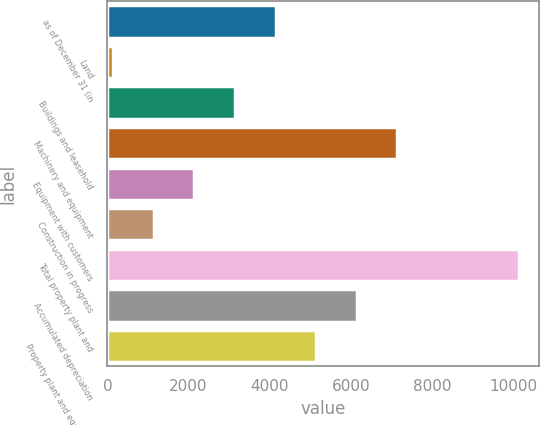Convert chart to OTSL. <chart><loc_0><loc_0><loc_500><loc_500><bar_chart><fcel>as of December 31 (in<fcel>Land<fcel>Buildings and leasehold<fcel>Machinery and equipment<fcel>Equipment with customers<fcel>Construction in progress<fcel>Total property plant and<fcel>Accumulated depreciation<fcel>Property plant and equipment<nl><fcel>4145.6<fcel>144<fcel>3145.2<fcel>7146.8<fcel>2144.8<fcel>1144.4<fcel>10148<fcel>6146.4<fcel>5146<nl></chart> 